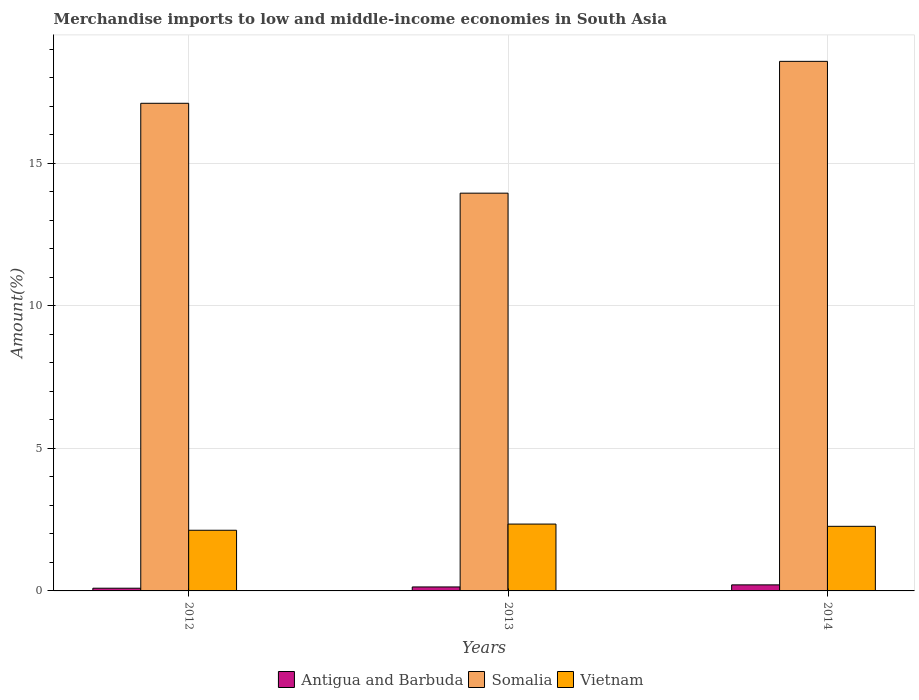Are the number of bars on each tick of the X-axis equal?
Keep it short and to the point. Yes. How many bars are there on the 1st tick from the right?
Give a very brief answer. 3. What is the percentage of amount earned from merchandise imports in Antigua and Barbuda in 2013?
Ensure brevity in your answer.  0.14. Across all years, what is the maximum percentage of amount earned from merchandise imports in Somalia?
Your response must be concise. 18.58. Across all years, what is the minimum percentage of amount earned from merchandise imports in Vietnam?
Keep it short and to the point. 2.13. In which year was the percentage of amount earned from merchandise imports in Somalia maximum?
Provide a short and direct response. 2014. What is the total percentage of amount earned from merchandise imports in Somalia in the graph?
Your response must be concise. 49.65. What is the difference between the percentage of amount earned from merchandise imports in Vietnam in 2013 and that in 2014?
Ensure brevity in your answer.  0.08. What is the difference between the percentage of amount earned from merchandise imports in Vietnam in 2014 and the percentage of amount earned from merchandise imports in Somalia in 2012?
Make the answer very short. -14.85. What is the average percentage of amount earned from merchandise imports in Vietnam per year?
Offer a terse response. 2.25. In the year 2014, what is the difference between the percentage of amount earned from merchandise imports in Antigua and Barbuda and percentage of amount earned from merchandise imports in Vietnam?
Ensure brevity in your answer.  -2.05. What is the ratio of the percentage of amount earned from merchandise imports in Somalia in 2012 to that in 2014?
Ensure brevity in your answer.  0.92. Is the percentage of amount earned from merchandise imports in Somalia in 2013 less than that in 2014?
Your answer should be very brief. Yes. Is the difference between the percentage of amount earned from merchandise imports in Antigua and Barbuda in 2013 and 2014 greater than the difference between the percentage of amount earned from merchandise imports in Vietnam in 2013 and 2014?
Give a very brief answer. No. What is the difference between the highest and the second highest percentage of amount earned from merchandise imports in Vietnam?
Your answer should be compact. 0.08. What is the difference between the highest and the lowest percentage of amount earned from merchandise imports in Vietnam?
Provide a succinct answer. 0.22. In how many years, is the percentage of amount earned from merchandise imports in Antigua and Barbuda greater than the average percentage of amount earned from merchandise imports in Antigua and Barbuda taken over all years?
Provide a succinct answer. 1. Is the sum of the percentage of amount earned from merchandise imports in Vietnam in 2013 and 2014 greater than the maximum percentage of amount earned from merchandise imports in Antigua and Barbuda across all years?
Your answer should be compact. Yes. What does the 2nd bar from the left in 2012 represents?
Keep it short and to the point. Somalia. What does the 2nd bar from the right in 2013 represents?
Provide a short and direct response. Somalia. Is it the case that in every year, the sum of the percentage of amount earned from merchandise imports in Somalia and percentage of amount earned from merchandise imports in Vietnam is greater than the percentage of amount earned from merchandise imports in Antigua and Barbuda?
Provide a short and direct response. Yes. How many years are there in the graph?
Offer a terse response. 3. What is the difference between two consecutive major ticks on the Y-axis?
Provide a short and direct response. 5. Are the values on the major ticks of Y-axis written in scientific E-notation?
Provide a succinct answer. No. Does the graph contain grids?
Keep it short and to the point. Yes. How many legend labels are there?
Provide a short and direct response. 3. What is the title of the graph?
Make the answer very short. Merchandise imports to low and middle-income economies in South Asia. What is the label or title of the X-axis?
Give a very brief answer. Years. What is the label or title of the Y-axis?
Offer a terse response. Amount(%). What is the Amount(%) in Antigua and Barbuda in 2012?
Offer a very short reply. 0.09. What is the Amount(%) of Somalia in 2012?
Make the answer very short. 17.11. What is the Amount(%) in Vietnam in 2012?
Your response must be concise. 2.13. What is the Amount(%) in Antigua and Barbuda in 2013?
Offer a terse response. 0.14. What is the Amount(%) of Somalia in 2013?
Your answer should be very brief. 13.96. What is the Amount(%) in Vietnam in 2013?
Your response must be concise. 2.35. What is the Amount(%) in Antigua and Barbuda in 2014?
Your answer should be very brief. 0.21. What is the Amount(%) in Somalia in 2014?
Your answer should be very brief. 18.58. What is the Amount(%) in Vietnam in 2014?
Offer a terse response. 2.27. Across all years, what is the maximum Amount(%) of Antigua and Barbuda?
Your response must be concise. 0.21. Across all years, what is the maximum Amount(%) of Somalia?
Give a very brief answer. 18.58. Across all years, what is the maximum Amount(%) of Vietnam?
Your answer should be very brief. 2.35. Across all years, what is the minimum Amount(%) in Antigua and Barbuda?
Keep it short and to the point. 0.09. Across all years, what is the minimum Amount(%) of Somalia?
Ensure brevity in your answer.  13.96. Across all years, what is the minimum Amount(%) of Vietnam?
Offer a very short reply. 2.13. What is the total Amount(%) in Antigua and Barbuda in the graph?
Offer a very short reply. 0.45. What is the total Amount(%) in Somalia in the graph?
Give a very brief answer. 49.65. What is the total Amount(%) of Vietnam in the graph?
Your response must be concise. 6.74. What is the difference between the Amount(%) in Antigua and Barbuda in 2012 and that in 2013?
Keep it short and to the point. -0.04. What is the difference between the Amount(%) of Somalia in 2012 and that in 2013?
Your answer should be very brief. 3.15. What is the difference between the Amount(%) in Vietnam in 2012 and that in 2013?
Make the answer very short. -0.22. What is the difference between the Amount(%) in Antigua and Barbuda in 2012 and that in 2014?
Keep it short and to the point. -0.12. What is the difference between the Amount(%) of Somalia in 2012 and that in 2014?
Your answer should be compact. -1.47. What is the difference between the Amount(%) of Vietnam in 2012 and that in 2014?
Your answer should be compact. -0.14. What is the difference between the Amount(%) in Antigua and Barbuda in 2013 and that in 2014?
Make the answer very short. -0.07. What is the difference between the Amount(%) of Somalia in 2013 and that in 2014?
Make the answer very short. -4.63. What is the difference between the Amount(%) of Vietnam in 2013 and that in 2014?
Give a very brief answer. 0.08. What is the difference between the Amount(%) in Antigua and Barbuda in 2012 and the Amount(%) in Somalia in 2013?
Your answer should be very brief. -13.86. What is the difference between the Amount(%) of Antigua and Barbuda in 2012 and the Amount(%) of Vietnam in 2013?
Keep it short and to the point. -2.25. What is the difference between the Amount(%) of Somalia in 2012 and the Amount(%) of Vietnam in 2013?
Keep it short and to the point. 14.77. What is the difference between the Amount(%) in Antigua and Barbuda in 2012 and the Amount(%) in Somalia in 2014?
Make the answer very short. -18.49. What is the difference between the Amount(%) of Antigua and Barbuda in 2012 and the Amount(%) of Vietnam in 2014?
Provide a succinct answer. -2.17. What is the difference between the Amount(%) in Somalia in 2012 and the Amount(%) in Vietnam in 2014?
Your response must be concise. 14.85. What is the difference between the Amount(%) in Antigua and Barbuda in 2013 and the Amount(%) in Somalia in 2014?
Provide a short and direct response. -18.44. What is the difference between the Amount(%) in Antigua and Barbuda in 2013 and the Amount(%) in Vietnam in 2014?
Ensure brevity in your answer.  -2.13. What is the difference between the Amount(%) in Somalia in 2013 and the Amount(%) in Vietnam in 2014?
Your answer should be very brief. 11.69. What is the average Amount(%) in Antigua and Barbuda per year?
Keep it short and to the point. 0.15. What is the average Amount(%) of Somalia per year?
Your answer should be very brief. 16.55. What is the average Amount(%) in Vietnam per year?
Offer a very short reply. 2.25. In the year 2012, what is the difference between the Amount(%) of Antigua and Barbuda and Amount(%) of Somalia?
Give a very brief answer. -17.02. In the year 2012, what is the difference between the Amount(%) of Antigua and Barbuda and Amount(%) of Vietnam?
Offer a very short reply. -2.03. In the year 2012, what is the difference between the Amount(%) of Somalia and Amount(%) of Vietnam?
Offer a terse response. 14.98. In the year 2013, what is the difference between the Amount(%) in Antigua and Barbuda and Amount(%) in Somalia?
Provide a succinct answer. -13.82. In the year 2013, what is the difference between the Amount(%) of Antigua and Barbuda and Amount(%) of Vietnam?
Your answer should be compact. -2.21. In the year 2013, what is the difference between the Amount(%) of Somalia and Amount(%) of Vietnam?
Provide a short and direct response. 11.61. In the year 2014, what is the difference between the Amount(%) in Antigua and Barbuda and Amount(%) in Somalia?
Your answer should be very brief. -18.37. In the year 2014, what is the difference between the Amount(%) of Antigua and Barbuda and Amount(%) of Vietnam?
Offer a terse response. -2.05. In the year 2014, what is the difference between the Amount(%) in Somalia and Amount(%) in Vietnam?
Provide a short and direct response. 16.32. What is the ratio of the Amount(%) of Antigua and Barbuda in 2012 to that in 2013?
Ensure brevity in your answer.  0.68. What is the ratio of the Amount(%) in Somalia in 2012 to that in 2013?
Give a very brief answer. 1.23. What is the ratio of the Amount(%) of Vietnam in 2012 to that in 2013?
Your response must be concise. 0.91. What is the ratio of the Amount(%) of Antigua and Barbuda in 2012 to that in 2014?
Your answer should be compact. 0.45. What is the ratio of the Amount(%) in Somalia in 2012 to that in 2014?
Your answer should be very brief. 0.92. What is the ratio of the Amount(%) of Vietnam in 2012 to that in 2014?
Your response must be concise. 0.94. What is the ratio of the Amount(%) in Antigua and Barbuda in 2013 to that in 2014?
Your answer should be compact. 0.66. What is the ratio of the Amount(%) of Somalia in 2013 to that in 2014?
Make the answer very short. 0.75. What is the ratio of the Amount(%) in Vietnam in 2013 to that in 2014?
Keep it short and to the point. 1.03. What is the difference between the highest and the second highest Amount(%) of Antigua and Barbuda?
Offer a terse response. 0.07. What is the difference between the highest and the second highest Amount(%) of Somalia?
Ensure brevity in your answer.  1.47. What is the difference between the highest and the second highest Amount(%) of Vietnam?
Your answer should be compact. 0.08. What is the difference between the highest and the lowest Amount(%) in Antigua and Barbuda?
Your response must be concise. 0.12. What is the difference between the highest and the lowest Amount(%) in Somalia?
Give a very brief answer. 4.63. What is the difference between the highest and the lowest Amount(%) in Vietnam?
Provide a short and direct response. 0.22. 